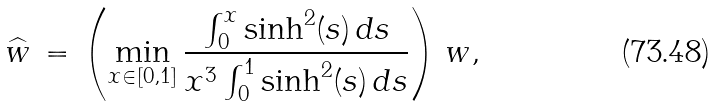Convert formula to latex. <formula><loc_0><loc_0><loc_500><loc_500>\widehat { w } \, = \, \left ( \min _ { x \in [ 0 , 1 ] } \frac { \int _ { 0 } ^ { x } \sinh ^ { 2 } ( s ) \, d s } { x ^ { 3 } \int _ { 0 } ^ { 1 } \sinh ^ { 2 } ( s ) \, d s } \right ) \, w ,</formula> 